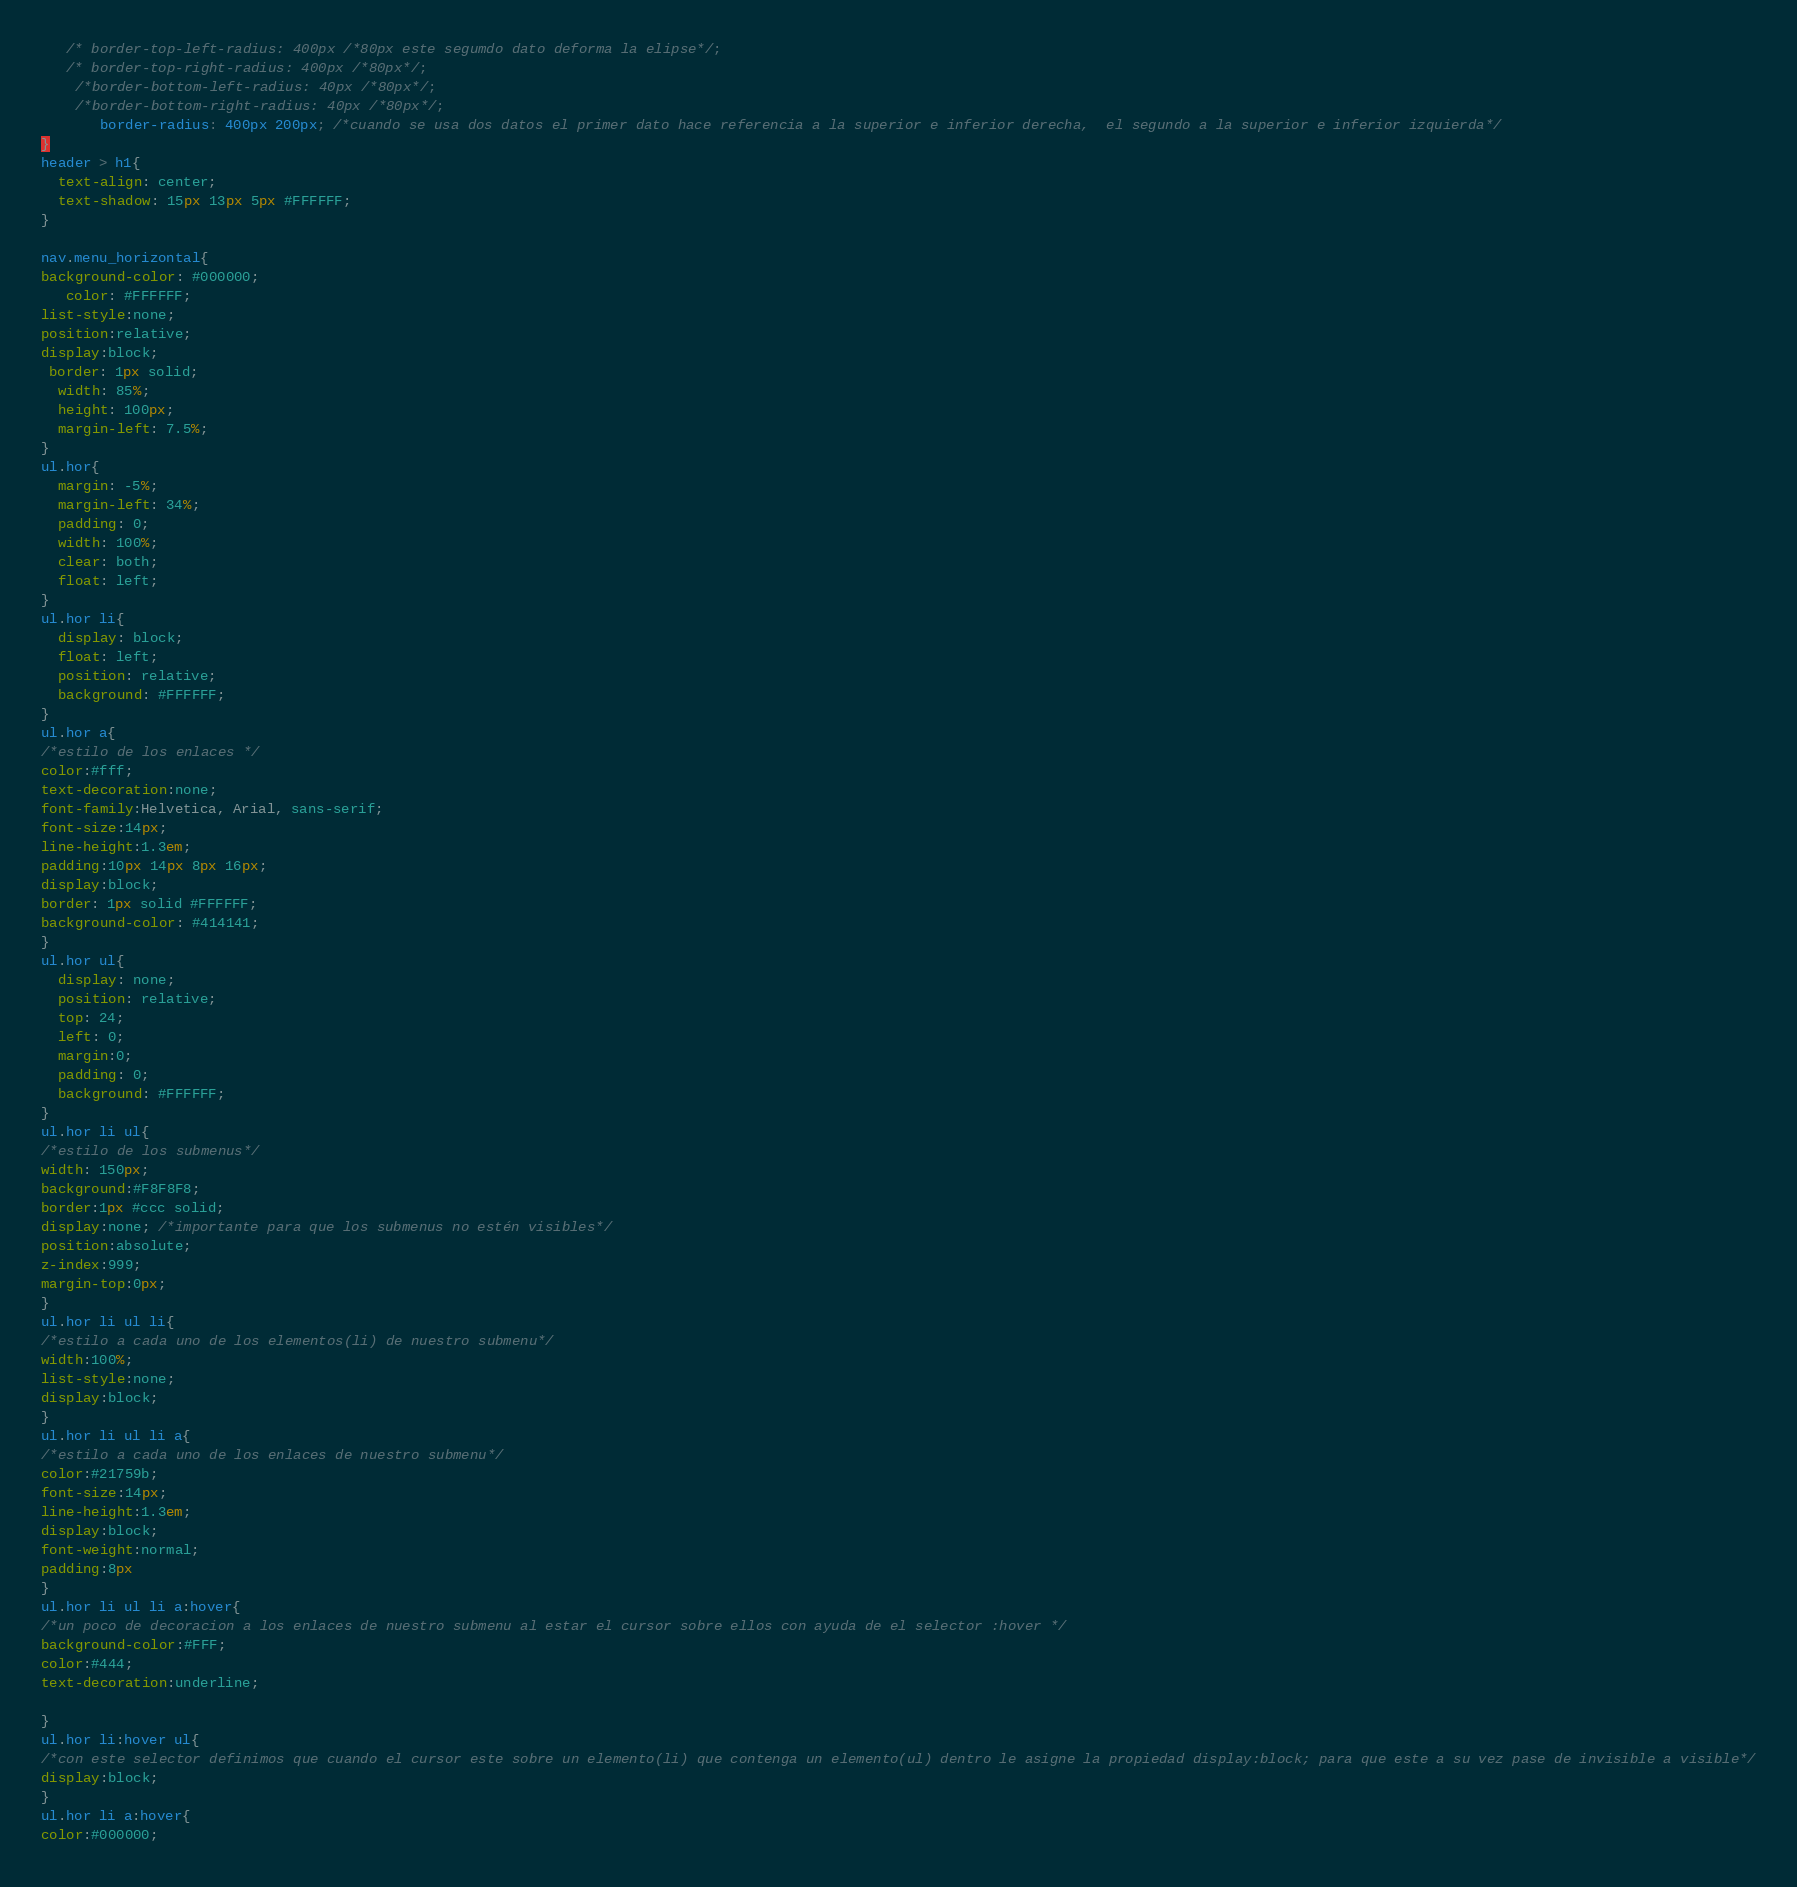<code> <loc_0><loc_0><loc_500><loc_500><_CSS_>   /* border-top-left-radius: 400px /*80px este segumdo dato deforma la elipse*/;
   /* border-top-right-radius: 400px /*80px*/;
    /*border-bottom-left-radius: 40px /*80px*/;
    /*border-bottom-right-radius: 40px /*80px*/;
       border-radius: 400px 200px; /*cuando se usa dos datos el primer dato hace referencia a la superior e inferior derecha,  el segundo a la superior e inferior izquierda*/
}
header > h1{
  text-align: center;
  text-shadow: 15px 13px 5px #FFFFFF;
}

nav.menu_horizontal{
background-color: #000000;
   color: #FFFFFF;
list-style:none;
position:relative;
display:block;
 border: 1px solid;
  width: 85%;
  height: 100px;
  margin-left: 7.5%;
}
ul.hor{
  margin: -5%;
  margin-left: 34%;
  padding: 0;
  width: 100%;
  clear: both;
  float: left;
}
ul.hor li{
  display: block;
  float: left;
  position: relative;
  background: #FFFFFF;
}
ul.hor a{
/*estilo de los enlaces */
color:#fff;
text-decoration:none;
font-family:Helvetica, Arial, sans-serif;
font-size:14px;
line-height:1.3em;
padding:10px 14px 8px 16px;
display:block;
border: 1px solid #FFFFFF;
background-color: #414141;
}
ul.hor ul{
  display: none;
  position: relative;
  top: 24;
  left: 0;
  margin:0;
  padding: 0;
  background: #FFFFFF;
}
ul.hor li ul{
/*estilo de los submenus*/
width: 150px;
background:#F8F8F8;
border:1px #ccc solid;
display:none; /*importante para que los submenus no estén visibles*/
position:absolute;
z-index:999;
margin-top:0px;
}
ul.hor li ul li{
/*estilo a cada uno de los elementos(li) de nuestro submenu*/
width:100%;
list-style:none;
display:block;
}
ul.hor li ul li a{
/*estilo a cada uno de los enlaces de nuestro submenu*/
color:#21759b;
font-size:14px;
line-height:1.3em;
display:block;
font-weight:normal;
padding:8px
}
ul.hor li ul li a:hover{
/*un poco de decoracion a los enlaces de nuestro submenu al estar el cursor sobre ellos con ayuda de el selector :hover */
background-color:#FFF;
color:#444;
text-decoration:underline;

}
ul.hor li:hover ul{
/*con este selector definimos que cuando el cursor este sobre un elemento(li) que contenga un elemento(ul) dentro le asigne la propiedad display:block; para que este a su vez pase de invisible a visible*/
display:block;
}
ul.hor li a:hover{
color:#000000;</code> 